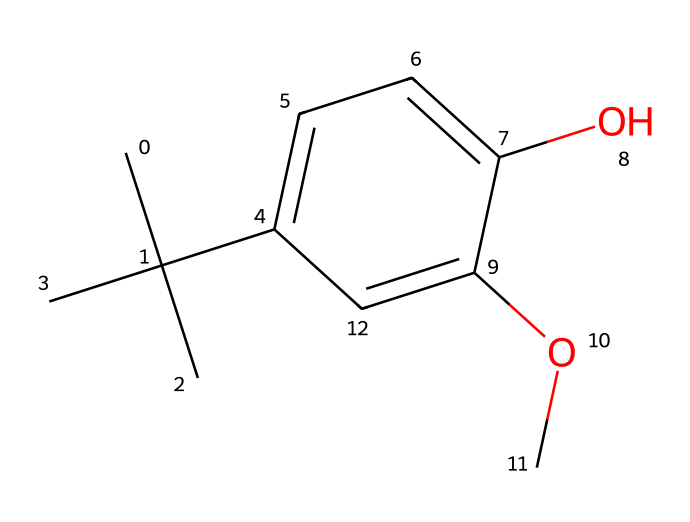What is the molecular formula of butylated hydroxyanisole (BHA)? To find the molecular formula, count the number of carbon (C), hydrogen (H), and oxygen (O) atoms in the structure based on the SMILES representation. There are 12 carbon atoms, 16 hydrogen atoms, and 2 oxygen atoms, leading to the formula C12H16O2.
Answer: C12H16O2 How many aromatic rings does the BHA structure contain? The SMILES shows one aromatic ring which can be identified by the 'c' characters, indicating carbon atoms in an aromatic system. Thus, there is a single aromatic ring in the structure.
Answer: 1 Which functional groups are present in BHA? By analyzing the structure, we can identify hydroxyl (OH) and ether (O-R) groups. The presence of -OH indicates a phenolic group, and the -O- with a methyl group attached shows an ether group; therefore, BHA contains both functional groups.
Answer: hydroxyl and ether What type of compound is BHA classified as? Given that BHA is used as a preservative and an antioxidant, it is classified as a phenolic antioxidant, which is identified through the presence of the aromatic ring and -OH group in its structure.
Answer: phenolic antioxidant What is the degree of unsaturation in the BHA structure? The degree of unsaturation can be calculated by examining the structure for rings and double bonds. Here, the presence of one ring (the aromatic ring) accounts for one degree of unsaturation. Thus, BHA has one degree of unsaturation.
Answer: 1 